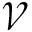Convert formula to latex. <formula><loc_0><loc_0><loc_500><loc_500>\mathcal { V }</formula> 